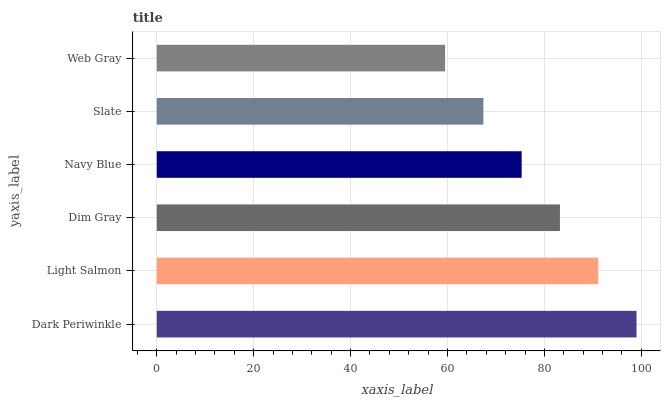Is Web Gray the minimum?
Answer yes or no. Yes. Is Dark Periwinkle the maximum?
Answer yes or no. Yes. Is Light Salmon the minimum?
Answer yes or no. No. Is Light Salmon the maximum?
Answer yes or no. No. Is Dark Periwinkle greater than Light Salmon?
Answer yes or no. Yes. Is Light Salmon less than Dark Periwinkle?
Answer yes or no. Yes. Is Light Salmon greater than Dark Periwinkle?
Answer yes or no. No. Is Dark Periwinkle less than Light Salmon?
Answer yes or no. No. Is Dim Gray the high median?
Answer yes or no. Yes. Is Navy Blue the low median?
Answer yes or no. Yes. Is Navy Blue the high median?
Answer yes or no. No. Is Slate the low median?
Answer yes or no. No. 